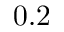Convert formula to latex. <formula><loc_0><loc_0><loc_500><loc_500>0 . 2</formula> 